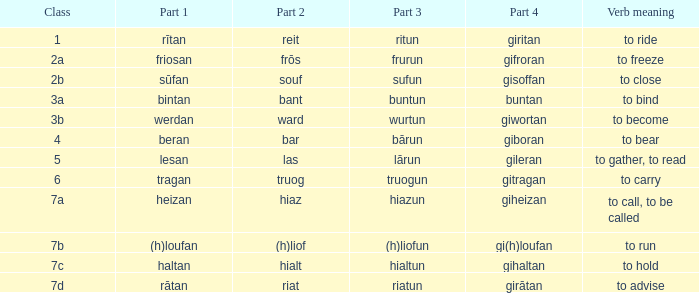What is the verb meaning of the word with part 2 "bant"? To bind. 